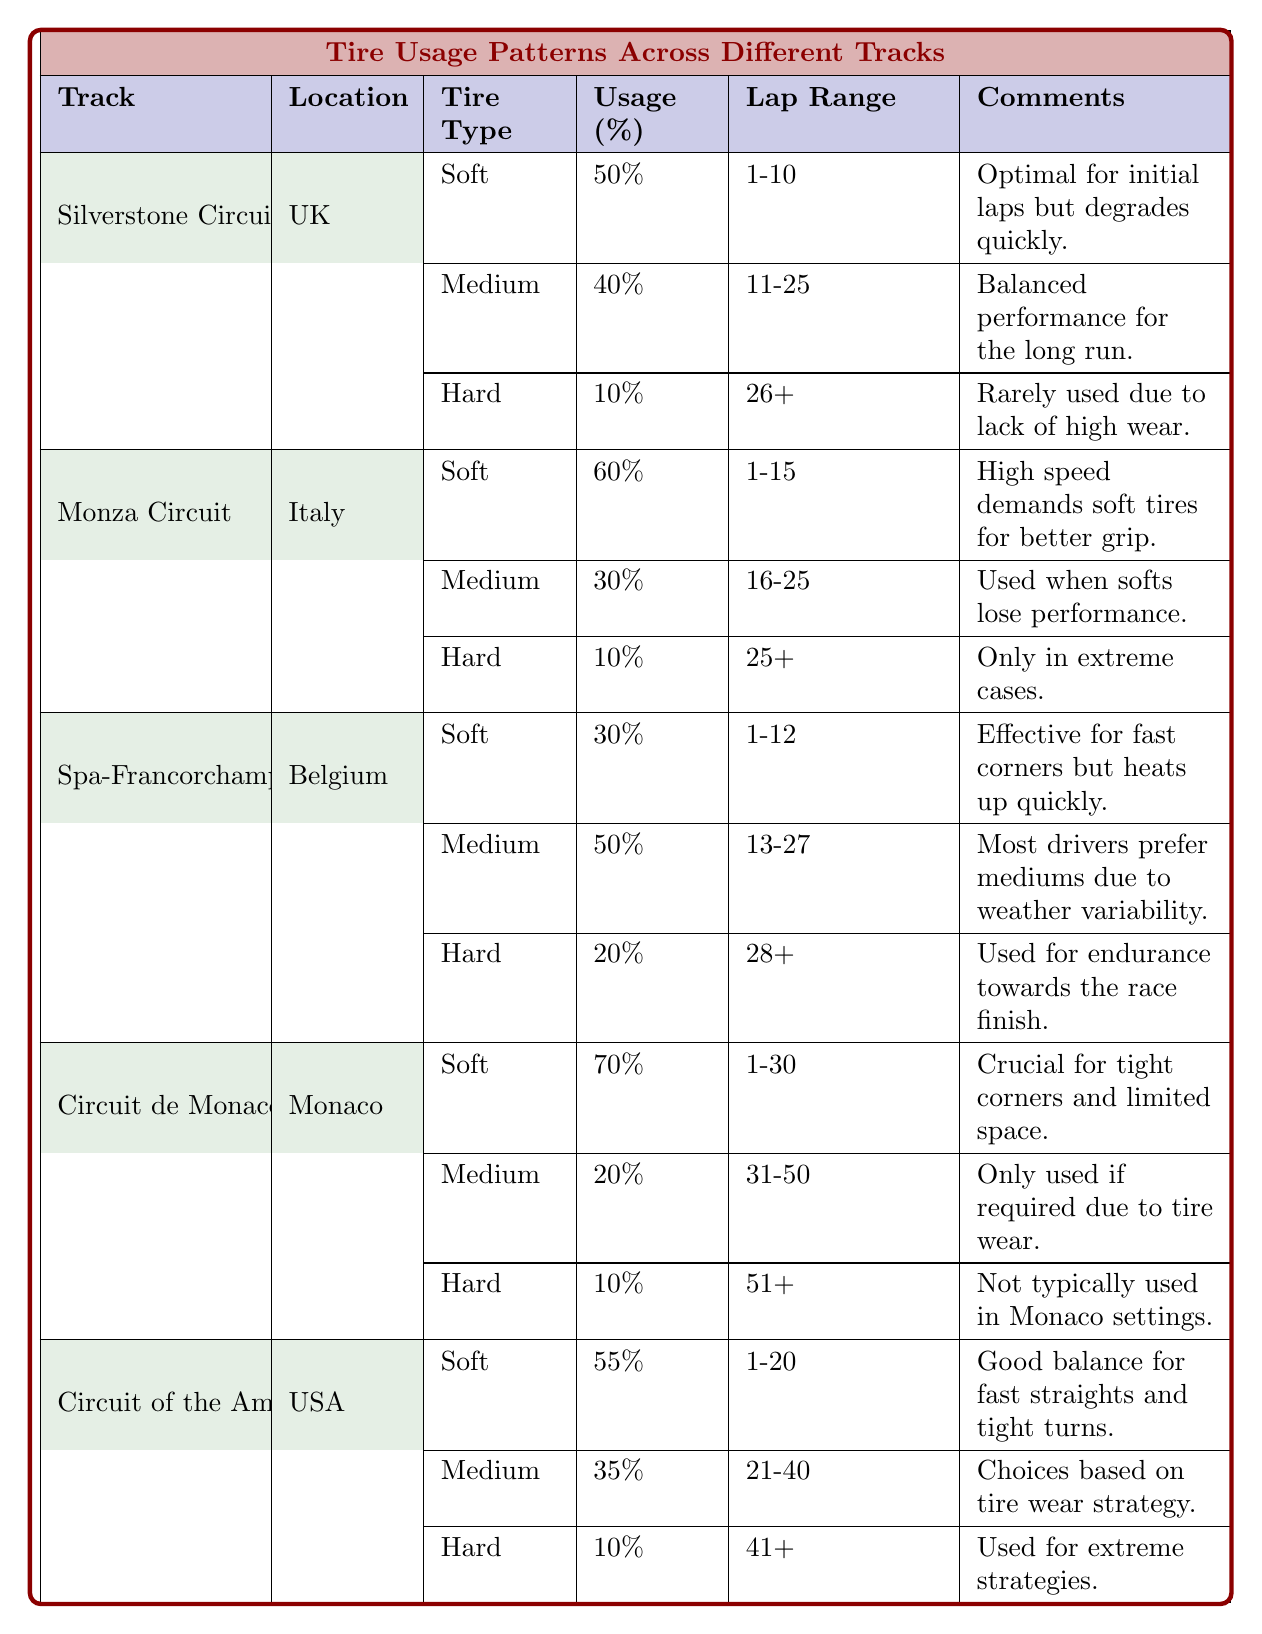What is the percentage of soft tire usage at the Circuit of the Americas? From the table, at the Circuit of the Americas, the soft tire usage is listed as 55%.
Answer: 55% Which tire type is used the least at Silverstone Circuit? The tire usage table shows that at Silverstone Circuit, the hard tire has a percentage usage of 10%, which is the lowest among soft, medium, and hard tires.
Answer: Hard How many tracks utilize hard tires for more than 10% of the total laps? By checking the data, only Spa-Francorchamps (20%) and Silverstone Circuit (10%) utilize hard tires, but Silverstone has exactly 10% while Spa has more than that. Therefore, the answer is just one track, Spa-Francorchamps.
Answer: 1 What is the average percentage of medium tire usage across all tracks? The percentages of medium tire usage are 40% (Silverstone), 30% (Monza), 50% (Spa), 20% (Monaco), and 35% (Circuit of the Americas). Adding them gives 40 + 30 + 50 + 20 + 35 = 175. Dividing by 5 (the total number of tracks) gives 175 / 5 = 35%.
Answer: 35% Is it true that the soft tires are used for more than 60% of the laps in any track? Checking the data, the Circuit de Monaco has the highest soft tire usage at 70%, which confirms that the statement is true.
Answer: Yes Which track has a higher percentage of medium tire usage: Monza or Spa-Francorchamps? According to the table, Monza has 30% medium tire usage, while Spa-Francorchamps has 50%. Since 50% is greater than 30%, Spa-Francorchamps has a higher percentage.
Answer: Spa-Francorchamps How much more often are soft tires used compared to hard tires at Circuit de Monaco? At Circuit de Monaco, soft tire usage is 70% and hard tire usage is 10%. The difference is 70 - 10 = 60%, indicating that soft tires are used 60% more often than hard tires.
Answer: 60% What is the common tire strategy idea among the tracks for medium tire usage? Examining the comments, all tracks mention tire strategy related to tire wear, performance loss, or balance with soft tires when they start degrading, indicating a common theme of using medium tires to maintain race pace during longer runs.
Answer: Consistency in managing tire wear strategy What tire type is primarily used for tight corners at the Monaco Circuit? The table specifies that soft tires are crucial for tight corners and limited space at the Monaco Circuit, indicating their primary usage for that track's characteristics.
Answer: Soft 